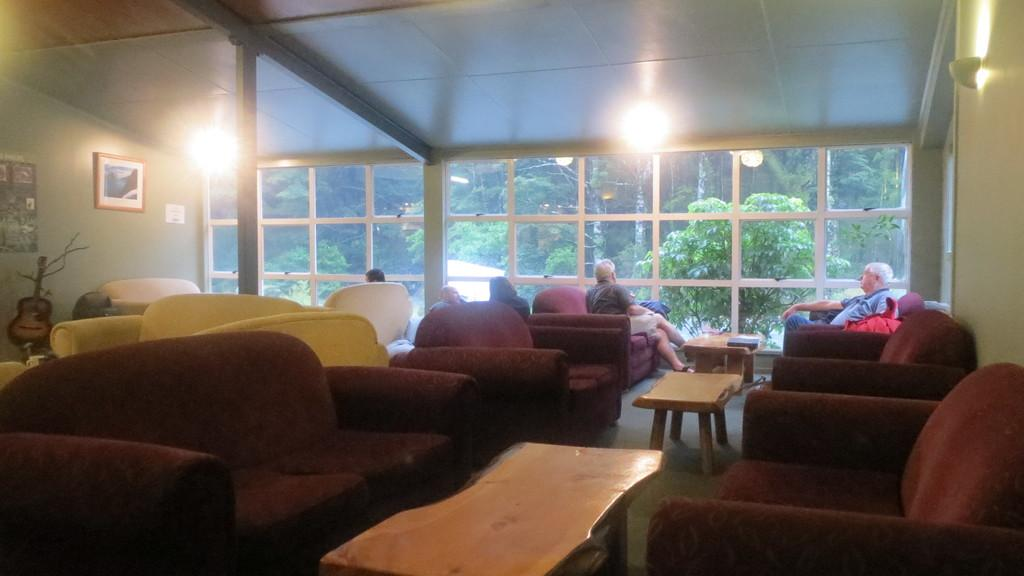What are the persons in the image doing? The persons in the image are sitting on sofas. What furniture can be seen in the image besides the sofas? There are tables in the image. What is on the wall in the image? There is a frame on the wall. What provides illumination in the image? There is a light source in the image. What type of natural scenery is visible in the image? There are trees visible in the image. What type of glass element is present in the image? There is a glass element in the image. What type of advertisement can be seen on the chin of the person sitting on the sofa? There is no advertisement visible on the chin of the person sitting on the sofa in the image. What type of creature is sitting on the sofa with the persons? There is no creature present in the image; only persons are visible. 